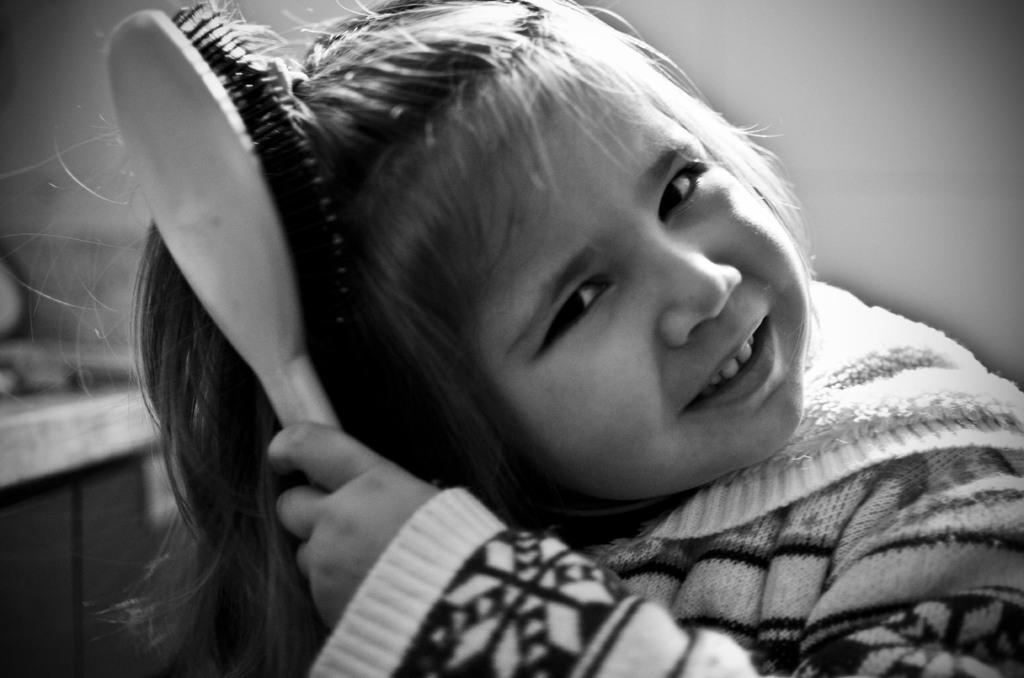What is the color scheme of the image? The image is black and white. Who is the main subject in the image? There is a girl in the image. What is the girl doing in the image? The girl is combing her hair. What can be seen in the background of the image? There is a wall in the background of the image. What type of rock is the girl standing on in the image? There is no rock present in the image; it is a black and white image of a girl combing her hair with a wall in the background. 